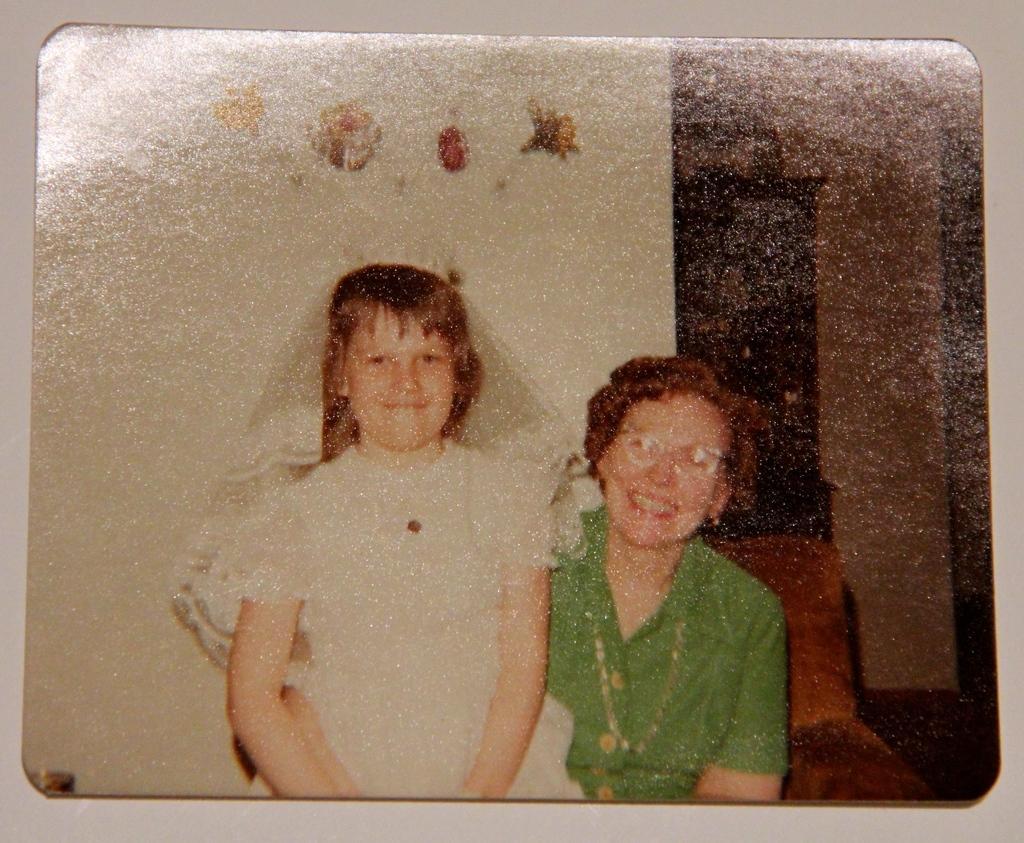Can you describe this image briefly? Here I can see a photo frame is attached to a wall. In the photo frame I can see a woman and a girl are smiling and giving pose for the picture. At the back of these people there is a wall and cupboard. 